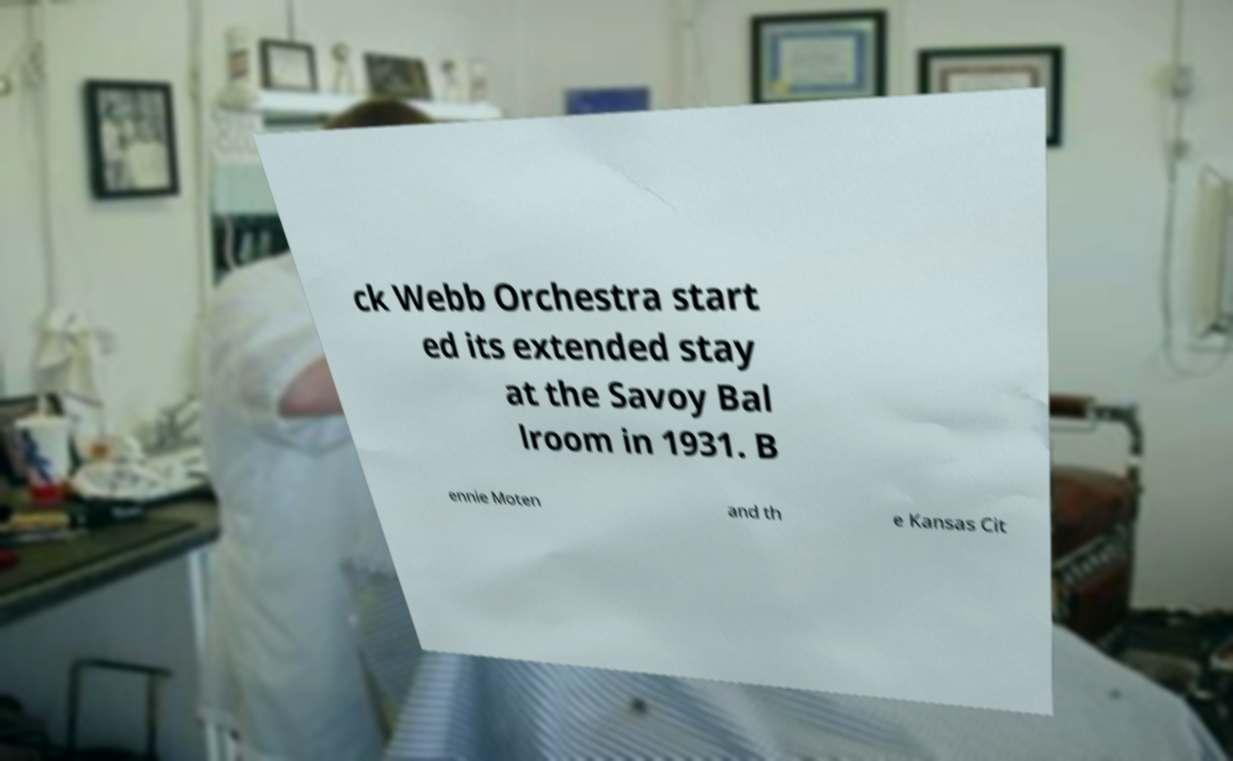I need the written content from this picture converted into text. Can you do that? ck Webb Orchestra start ed its extended stay at the Savoy Bal lroom in 1931. B ennie Moten and th e Kansas Cit 